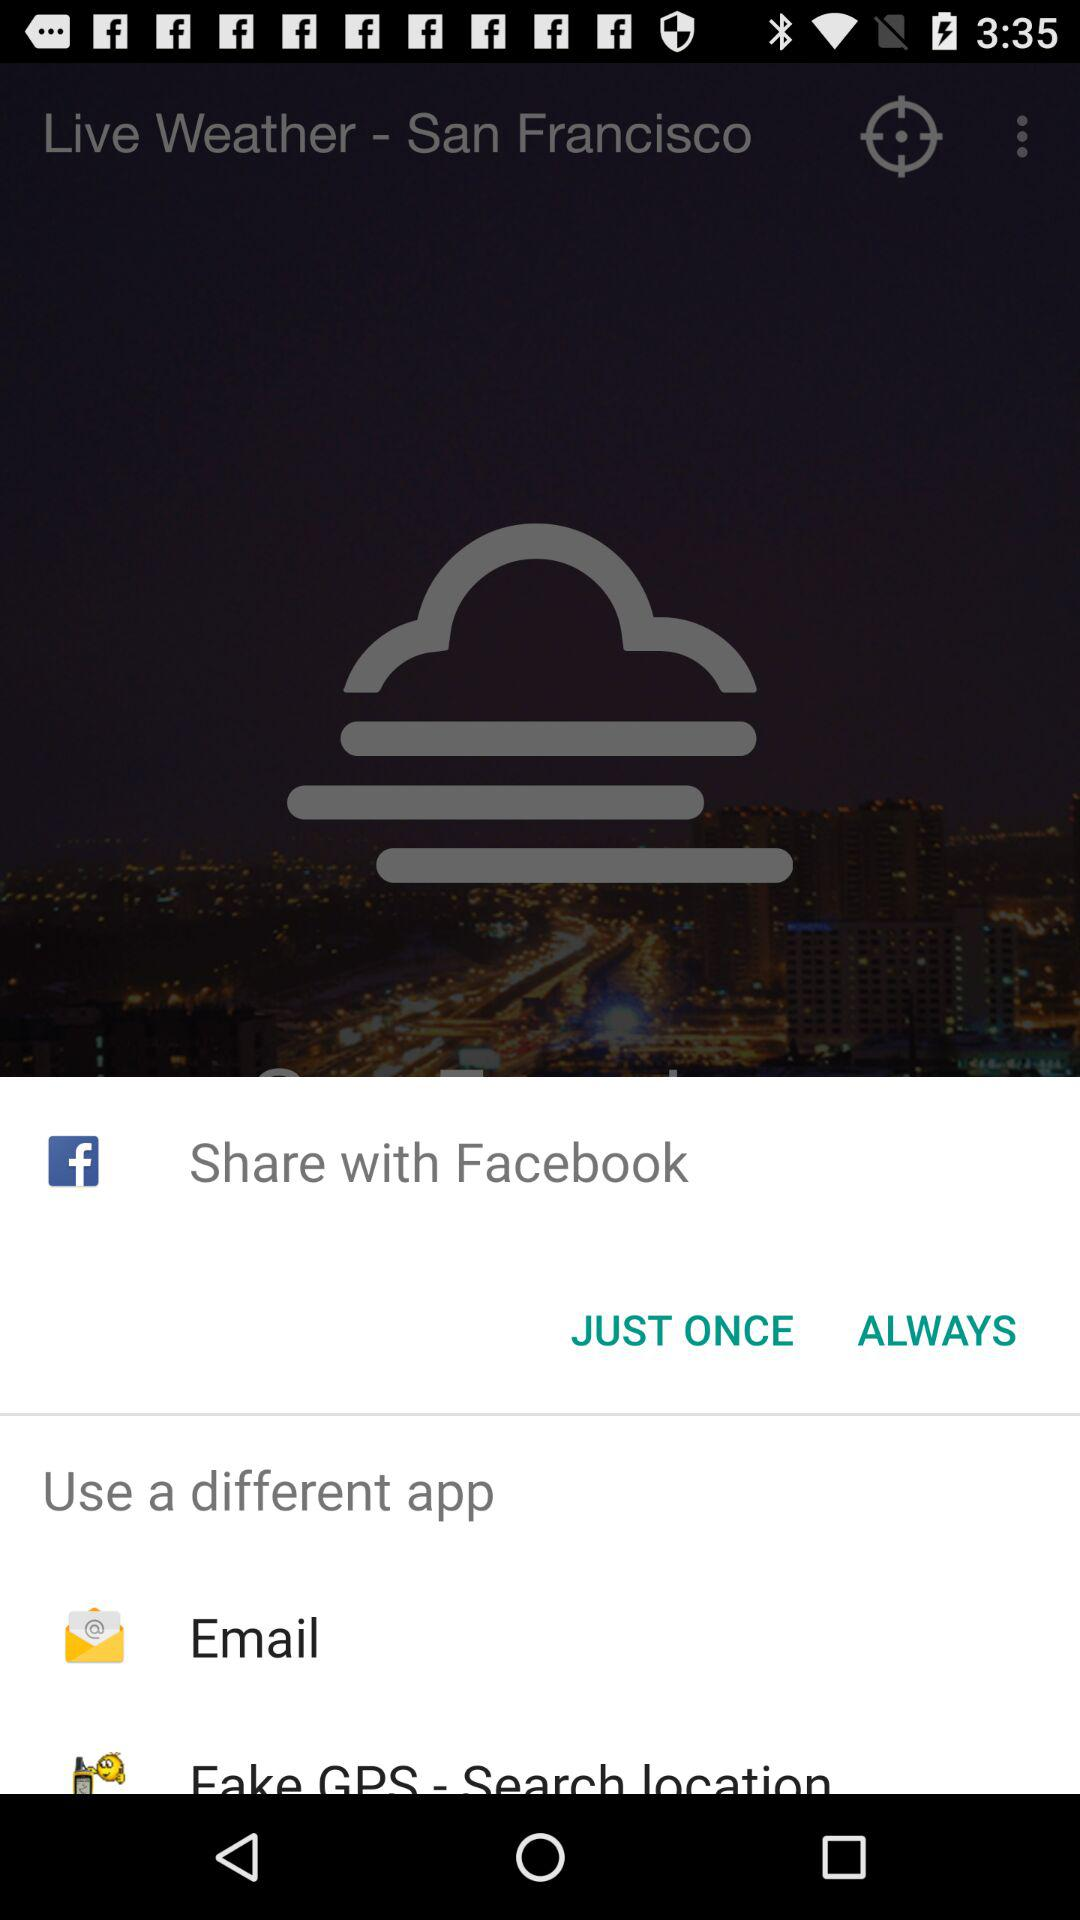Which applications are used to share? The applications used to share are "Facebook" and "Email". 